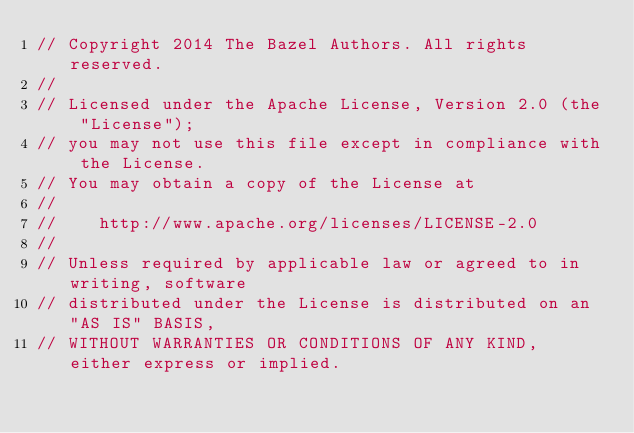Convert code to text. <code><loc_0><loc_0><loc_500><loc_500><_Java_>// Copyright 2014 The Bazel Authors. All rights reserved.
//
// Licensed under the Apache License, Version 2.0 (the "License");
// you may not use this file except in compliance with the License.
// You may obtain a copy of the License at
//
//    http://www.apache.org/licenses/LICENSE-2.0
//
// Unless required by applicable law or agreed to in writing, software
// distributed under the License is distributed on an "AS IS" BASIS,
// WITHOUT WARRANTIES OR CONDITIONS OF ANY KIND, either express or implied.</code> 